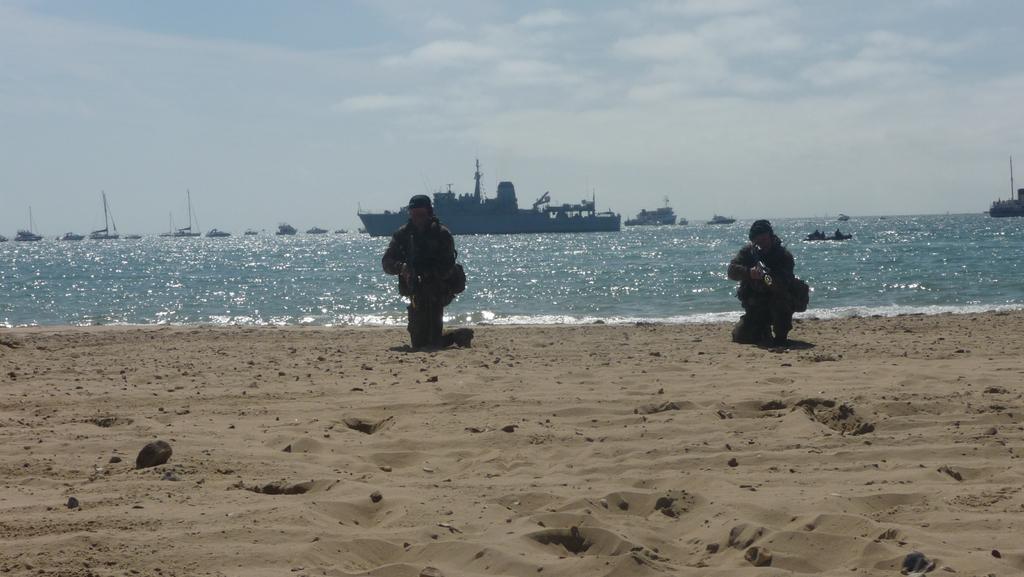Describe this image in one or two sentences. In this image I can see sand, water, clouds, the sky and in water I can see number of boats and a ship. Here I can see two persons. 